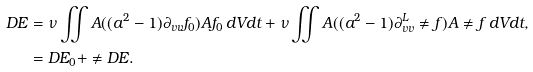Convert formula to latex. <formula><loc_0><loc_0><loc_500><loc_500>D E & = \nu \iint A ( ( a ^ { 2 } - 1 ) \partial _ { v v } f _ { 0 } ) A f _ { 0 } \, d V d t + \nu \iint A ( ( a ^ { 2 } - 1 ) \partial ^ { L } _ { v v } \ne { f } ) A \ne { f } \, d V d t , \\ & = D E _ { 0 } + \ne { D E } .</formula> 